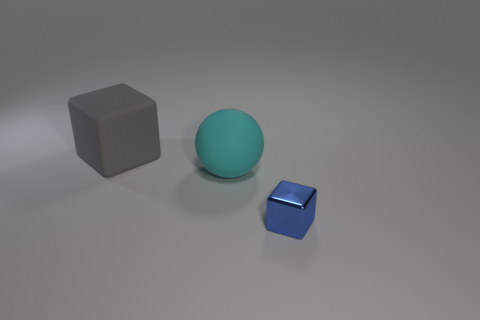How many objects are both behind the small cube and on the right side of the big gray cube?
Offer a terse response. 1. What material is the tiny object that is the same shape as the large gray rubber object?
Provide a succinct answer. Metal. Is there any other thing that is made of the same material as the blue block?
Your answer should be very brief. No. Are there an equal number of large matte things that are left of the large gray block and objects that are behind the small cube?
Provide a succinct answer. No. Is the sphere made of the same material as the gray cube?
Your answer should be compact. Yes. What number of cyan objects are either small shiny cubes or blocks?
Provide a succinct answer. 0. What number of other things are the same shape as the blue object?
Give a very brief answer. 1. What is the material of the small block?
Give a very brief answer. Metal. Are there an equal number of tiny blue things that are behind the cyan ball and large purple rubber spheres?
Ensure brevity in your answer.  Yes. There is another object that is the same size as the cyan object; what shape is it?
Your answer should be very brief. Cube. 